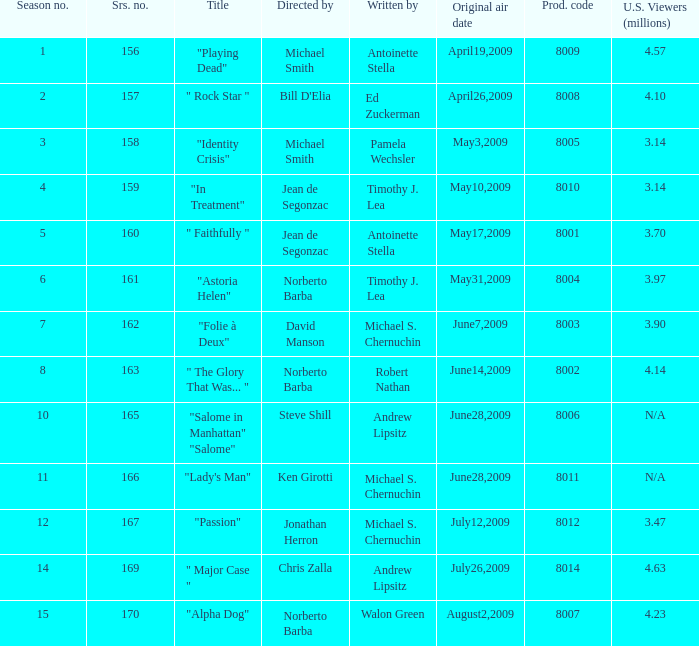Which is the biggest production code? 8014.0. 